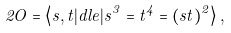<formula> <loc_0><loc_0><loc_500><loc_500>2 O = \left < s , t | d l e | s ^ { 3 } = t ^ { 4 } = ( s t ) ^ { 2 } \right > ,</formula> 